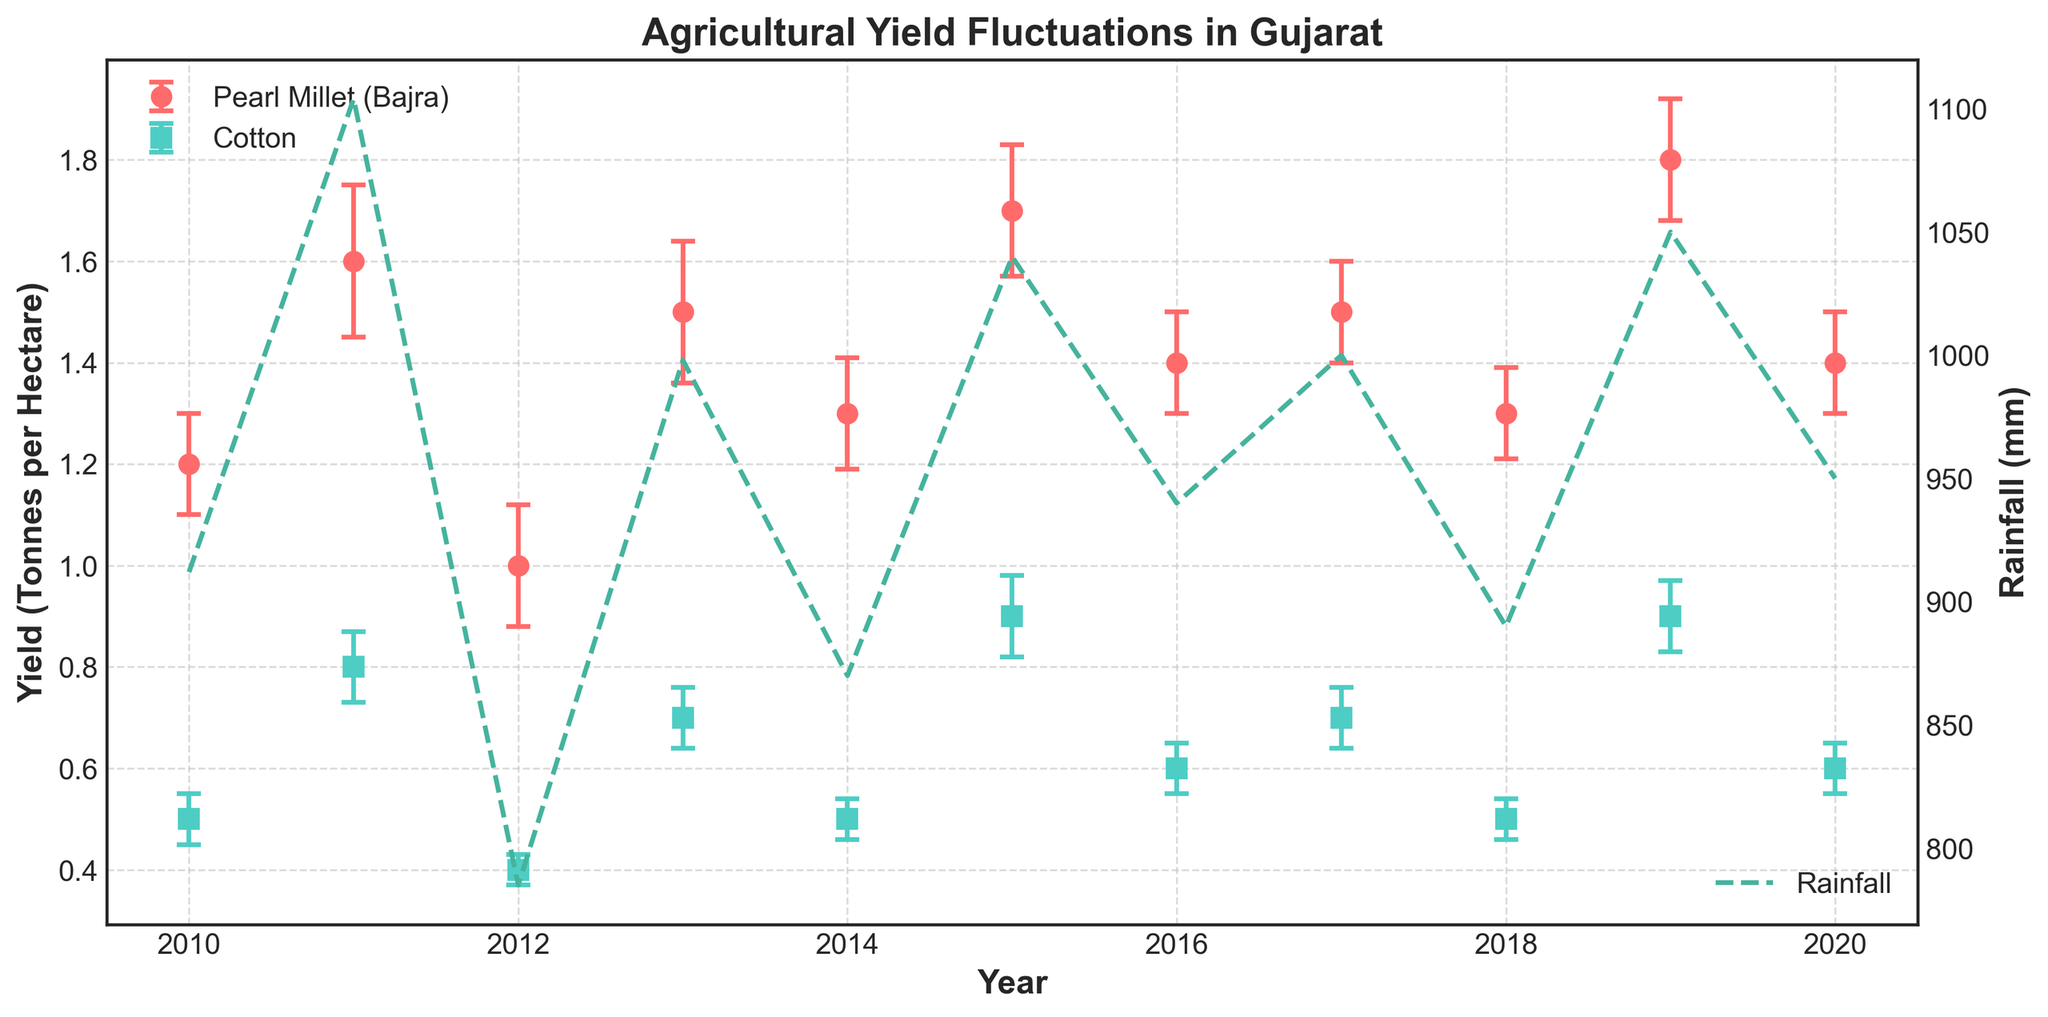What is the title of the figure? The title of the figure is usually placed at the top of the chart and describes the main topic of the visualization. In this case, the title is "Agricultural Yield Fluctuations in Gujarat".
Answer: Agricultural Yield Fluctuations in Gujarat Which crops are shown in the line plot? The crops are usually indicated in the legend of the plot. Here, the legend shows two crops: Pearl Millet (Bajra) and Cotton.
Answer: Pearl Millet (Bajra) and Cotton What is the range of yield (Tonnes per Hectare) for Cotton from 2010 to 2020? By looking at the line plot for Cotton (represented by ‘s’ markers), the yield fluctuates between 0.4 and 0.9 tonnes per hectare over the years from 2010 to 2020.
Answer: 0.4 to 0.9 tonnes per hectare How does the rainfall trend compare to the yield trend for both crops from 2010 to 2020? To compare the trends, look at both the line plot of yield and the dashed line plot for rainfall. Generally, rainfall correlates positively with yield increases; years with higher yields like 2011, 2015, and 2019 coincide with higher rainfall. Conversely, lower yields such as 2012 had lower rainfall.
Answer: Positive correlation In which year did Pearl Millet (Bajra) have the highest yield, and what was the rainfall that year? Identify the peak point in the line plot for Pearl Millet, which occurs in 2019. Correspondingly, the rainfall for 2019 can be read from the dashed line plot on the secondary y-axis.
Answer: 2019, 1050 mm What is the difference between the highest and lowest yields for Cotton? The highest yield for Cotton happens in 2015 and 2019 with 0.9 tonnes per hectare, and the lowest yield in 2012 with 0.4 tonnes per hectare. The difference is calculated by subtracting the smallest value from the largest value.
Answer: 0.5 tonnes per hectare Which crop shows a more significant fluctuation in yield over the years, and how do you know? Compare the spread of data points and error bars for both crops. Pearl Millet (Bajra) shows more significant fluctuation as its yield values and error margins vary more widely compared to Cotton. This can be seen as the yield range for Pearl Millet is from 1.0 to 1.8 tonnes per hectare, whereas Cotton is from 0.4 to 0.9.
Answer: Pearl Millet (Bajra) During which years did both crops show a decline in yield compared to previous years? Identify the years where the respective lines for both crops slope downward from the previous year. For both Pearl Millet and Cotton, there is a visible decline from 2015 to 2016 and from 2019 to 2020.
Answer: 2016, 2020 What is the average rainfall over the decade (2010-2020)? Add all the yearly rainfall values and divide by the number of years (11). Specifically: (912 + 1104 + 785 + 998 + 870 + 1040 + 940 + 1000 + 890 + 1050 + 950) / 11 = 959.27 mm.
Answer: 959.27 mm By how much did Pearl Millet (Bajra) yield change from 2010 to 2011, and what could be a contributing factor? Calculate the difference in Yield for Pearl Millet between 2010 and 2011 by subtracting the 2010 value from the 2011 value: 1.6 - 1.2 = 0.4. The corresponding increase in rainfall from 912 mm to 1104 mm could be a contributing factor.
Answer: 0.4 Tonnes per Hectare, Increase in rainfall 